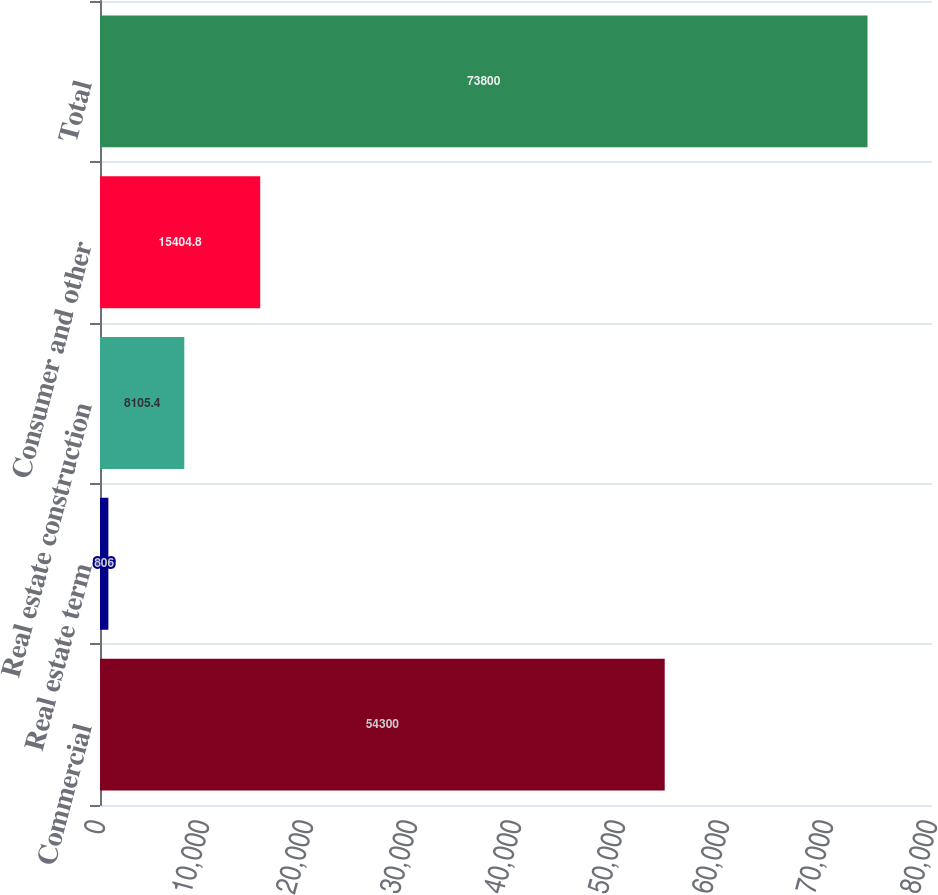Convert chart. <chart><loc_0><loc_0><loc_500><loc_500><bar_chart><fcel>Commercial<fcel>Real estate term<fcel>Real estate construction<fcel>Consumer and other<fcel>Total<nl><fcel>54300<fcel>806<fcel>8105.4<fcel>15404.8<fcel>73800<nl></chart> 